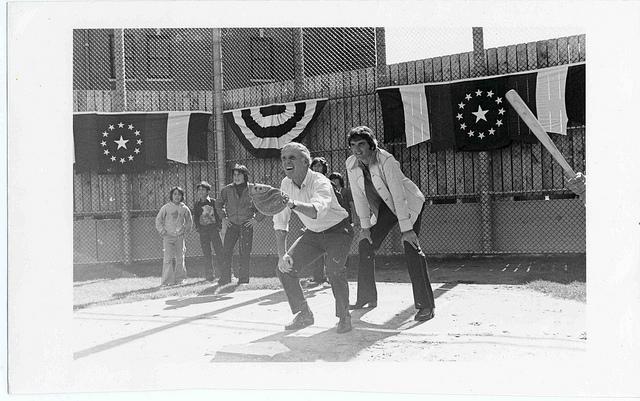Are they playing baseball?
Keep it brief. Yes. Is it dark in the photo?
Answer briefly. No. What colors are the banners in the background?
Write a very short answer. Red white and blue. Is the photo in color?
Short answer required. No. What is on the boy's back?
Keep it brief. Jacket. What flag is in the background?
Be succinct. American. 